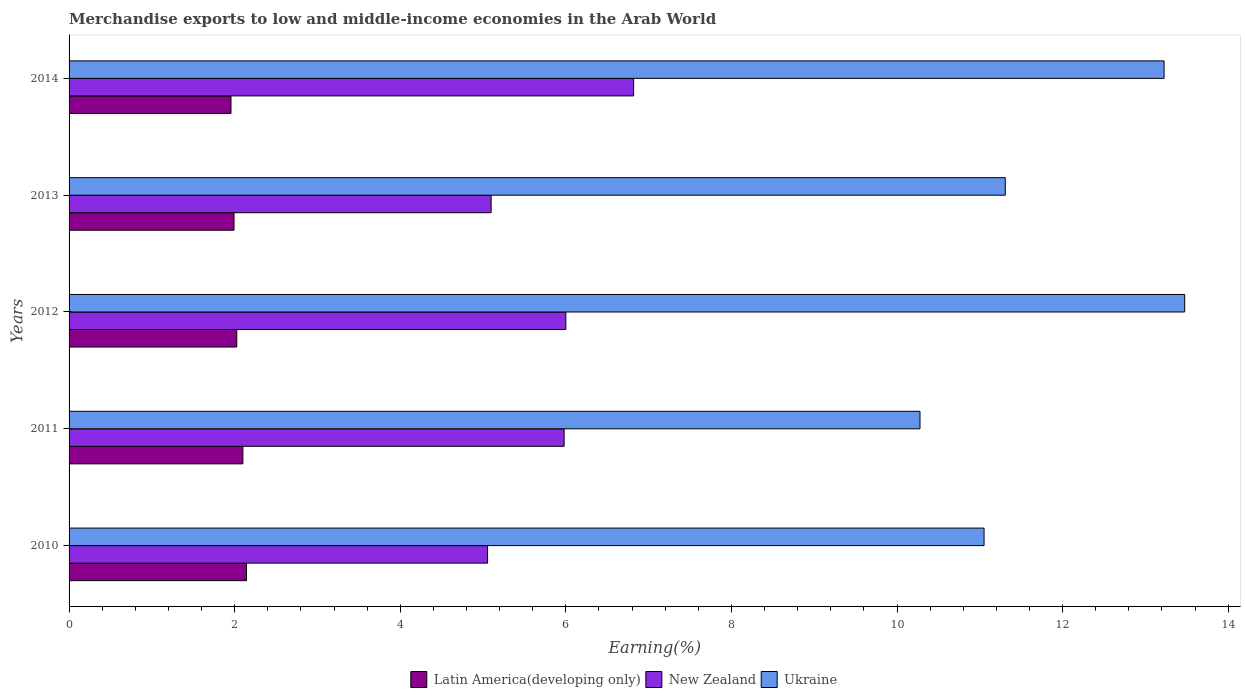How many different coloured bars are there?
Provide a short and direct response. 3. How many groups of bars are there?
Make the answer very short. 5. Are the number of bars on each tick of the Y-axis equal?
Give a very brief answer. Yes. In how many cases, is the number of bars for a given year not equal to the number of legend labels?
Your answer should be very brief. 0. What is the percentage of amount earned from merchandise exports in New Zealand in 2011?
Give a very brief answer. 5.98. Across all years, what is the maximum percentage of amount earned from merchandise exports in Ukraine?
Keep it short and to the point. 13.47. Across all years, what is the minimum percentage of amount earned from merchandise exports in Ukraine?
Your response must be concise. 10.28. In which year was the percentage of amount earned from merchandise exports in New Zealand maximum?
Offer a very short reply. 2014. What is the total percentage of amount earned from merchandise exports in Latin America(developing only) in the graph?
Your response must be concise. 10.22. What is the difference between the percentage of amount earned from merchandise exports in New Zealand in 2011 and that in 2012?
Your response must be concise. -0.02. What is the difference between the percentage of amount earned from merchandise exports in New Zealand in 2011 and the percentage of amount earned from merchandise exports in Latin America(developing only) in 2012?
Offer a very short reply. 3.95. What is the average percentage of amount earned from merchandise exports in Ukraine per year?
Your answer should be compact. 11.87. In the year 2014, what is the difference between the percentage of amount earned from merchandise exports in New Zealand and percentage of amount earned from merchandise exports in Latin America(developing only)?
Give a very brief answer. 4.86. What is the ratio of the percentage of amount earned from merchandise exports in Latin America(developing only) in 2011 to that in 2014?
Give a very brief answer. 1.07. What is the difference between the highest and the second highest percentage of amount earned from merchandise exports in Latin America(developing only)?
Offer a terse response. 0.04. What is the difference between the highest and the lowest percentage of amount earned from merchandise exports in Ukraine?
Provide a short and direct response. 3.2. Is the sum of the percentage of amount earned from merchandise exports in Latin America(developing only) in 2011 and 2014 greater than the maximum percentage of amount earned from merchandise exports in Ukraine across all years?
Ensure brevity in your answer.  No. What does the 1st bar from the top in 2011 represents?
Your response must be concise. Ukraine. What does the 3rd bar from the bottom in 2011 represents?
Ensure brevity in your answer.  Ukraine. What is the difference between two consecutive major ticks on the X-axis?
Ensure brevity in your answer.  2. Are the values on the major ticks of X-axis written in scientific E-notation?
Your answer should be very brief. No. Does the graph contain any zero values?
Make the answer very short. No. How many legend labels are there?
Keep it short and to the point. 3. How are the legend labels stacked?
Your answer should be very brief. Horizontal. What is the title of the graph?
Your answer should be very brief. Merchandise exports to low and middle-income economies in the Arab World. What is the label or title of the X-axis?
Your answer should be very brief. Earning(%). What is the label or title of the Y-axis?
Ensure brevity in your answer.  Years. What is the Earning(%) in Latin America(developing only) in 2010?
Your answer should be compact. 2.14. What is the Earning(%) in New Zealand in 2010?
Offer a very short reply. 5.05. What is the Earning(%) of Ukraine in 2010?
Your answer should be compact. 11.05. What is the Earning(%) in Latin America(developing only) in 2011?
Your response must be concise. 2.1. What is the Earning(%) in New Zealand in 2011?
Keep it short and to the point. 5.98. What is the Earning(%) of Ukraine in 2011?
Offer a very short reply. 10.28. What is the Earning(%) in Latin America(developing only) in 2012?
Keep it short and to the point. 2.03. What is the Earning(%) in New Zealand in 2012?
Your response must be concise. 6. What is the Earning(%) in Ukraine in 2012?
Your answer should be very brief. 13.47. What is the Earning(%) of Latin America(developing only) in 2013?
Give a very brief answer. 1.99. What is the Earning(%) in New Zealand in 2013?
Offer a very short reply. 5.1. What is the Earning(%) of Ukraine in 2013?
Give a very brief answer. 11.31. What is the Earning(%) in Latin America(developing only) in 2014?
Provide a short and direct response. 1.96. What is the Earning(%) of New Zealand in 2014?
Your response must be concise. 6.82. What is the Earning(%) in Ukraine in 2014?
Offer a terse response. 13.23. Across all years, what is the maximum Earning(%) in Latin America(developing only)?
Your answer should be very brief. 2.14. Across all years, what is the maximum Earning(%) in New Zealand?
Give a very brief answer. 6.82. Across all years, what is the maximum Earning(%) of Ukraine?
Make the answer very short. 13.47. Across all years, what is the minimum Earning(%) of Latin America(developing only)?
Offer a very short reply. 1.96. Across all years, what is the minimum Earning(%) in New Zealand?
Ensure brevity in your answer.  5.05. Across all years, what is the minimum Earning(%) of Ukraine?
Make the answer very short. 10.28. What is the total Earning(%) of Latin America(developing only) in the graph?
Provide a short and direct response. 10.22. What is the total Earning(%) of New Zealand in the graph?
Make the answer very short. 28.95. What is the total Earning(%) of Ukraine in the graph?
Your answer should be very brief. 59.34. What is the difference between the Earning(%) in Latin America(developing only) in 2010 and that in 2011?
Make the answer very short. 0.04. What is the difference between the Earning(%) of New Zealand in 2010 and that in 2011?
Your response must be concise. -0.92. What is the difference between the Earning(%) in Ukraine in 2010 and that in 2011?
Keep it short and to the point. 0.77. What is the difference between the Earning(%) of Latin America(developing only) in 2010 and that in 2012?
Give a very brief answer. 0.12. What is the difference between the Earning(%) of New Zealand in 2010 and that in 2012?
Offer a terse response. -0.95. What is the difference between the Earning(%) of Ukraine in 2010 and that in 2012?
Offer a very short reply. -2.42. What is the difference between the Earning(%) in Latin America(developing only) in 2010 and that in 2013?
Provide a succinct answer. 0.15. What is the difference between the Earning(%) of New Zealand in 2010 and that in 2013?
Give a very brief answer. -0.04. What is the difference between the Earning(%) of Ukraine in 2010 and that in 2013?
Keep it short and to the point. -0.26. What is the difference between the Earning(%) of Latin America(developing only) in 2010 and that in 2014?
Give a very brief answer. 0.19. What is the difference between the Earning(%) in New Zealand in 2010 and that in 2014?
Your answer should be compact. -1.76. What is the difference between the Earning(%) of Ukraine in 2010 and that in 2014?
Provide a short and direct response. -2.17. What is the difference between the Earning(%) of Latin America(developing only) in 2011 and that in 2012?
Give a very brief answer. 0.07. What is the difference between the Earning(%) of New Zealand in 2011 and that in 2012?
Your answer should be compact. -0.02. What is the difference between the Earning(%) in Ukraine in 2011 and that in 2012?
Your answer should be very brief. -3.2. What is the difference between the Earning(%) of Latin America(developing only) in 2011 and that in 2013?
Your answer should be compact. 0.11. What is the difference between the Earning(%) of New Zealand in 2011 and that in 2013?
Ensure brevity in your answer.  0.88. What is the difference between the Earning(%) of Ukraine in 2011 and that in 2013?
Ensure brevity in your answer.  -1.03. What is the difference between the Earning(%) of Latin America(developing only) in 2011 and that in 2014?
Provide a short and direct response. 0.14. What is the difference between the Earning(%) in New Zealand in 2011 and that in 2014?
Offer a very short reply. -0.84. What is the difference between the Earning(%) of Ukraine in 2011 and that in 2014?
Ensure brevity in your answer.  -2.95. What is the difference between the Earning(%) in Latin America(developing only) in 2012 and that in 2013?
Your response must be concise. 0.03. What is the difference between the Earning(%) in New Zealand in 2012 and that in 2013?
Ensure brevity in your answer.  0.9. What is the difference between the Earning(%) in Ukraine in 2012 and that in 2013?
Offer a terse response. 2.17. What is the difference between the Earning(%) of Latin America(developing only) in 2012 and that in 2014?
Provide a succinct answer. 0.07. What is the difference between the Earning(%) in New Zealand in 2012 and that in 2014?
Provide a succinct answer. -0.82. What is the difference between the Earning(%) of Ukraine in 2012 and that in 2014?
Make the answer very short. 0.25. What is the difference between the Earning(%) of Latin America(developing only) in 2013 and that in 2014?
Give a very brief answer. 0.04. What is the difference between the Earning(%) of New Zealand in 2013 and that in 2014?
Offer a terse response. -1.72. What is the difference between the Earning(%) of Ukraine in 2013 and that in 2014?
Keep it short and to the point. -1.92. What is the difference between the Earning(%) of Latin America(developing only) in 2010 and the Earning(%) of New Zealand in 2011?
Ensure brevity in your answer.  -3.84. What is the difference between the Earning(%) of Latin America(developing only) in 2010 and the Earning(%) of Ukraine in 2011?
Offer a very short reply. -8.13. What is the difference between the Earning(%) of New Zealand in 2010 and the Earning(%) of Ukraine in 2011?
Your answer should be compact. -5.22. What is the difference between the Earning(%) of Latin America(developing only) in 2010 and the Earning(%) of New Zealand in 2012?
Provide a short and direct response. -3.86. What is the difference between the Earning(%) of Latin America(developing only) in 2010 and the Earning(%) of Ukraine in 2012?
Ensure brevity in your answer.  -11.33. What is the difference between the Earning(%) of New Zealand in 2010 and the Earning(%) of Ukraine in 2012?
Provide a succinct answer. -8.42. What is the difference between the Earning(%) in Latin America(developing only) in 2010 and the Earning(%) in New Zealand in 2013?
Keep it short and to the point. -2.95. What is the difference between the Earning(%) of Latin America(developing only) in 2010 and the Earning(%) of Ukraine in 2013?
Your answer should be very brief. -9.17. What is the difference between the Earning(%) in New Zealand in 2010 and the Earning(%) in Ukraine in 2013?
Provide a short and direct response. -6.25. What is the difference between the Earning(%) of Latin America(developing only) in 2010 and the Earning(%) of New Zealand in 2014?
Keep it short and to the point. -4.68. What is the difference between the Earning(%) in Latin America(developing only) in 2010 and the Earning(%) in Ukraine in 2014?
Offer a terse response. -11.08. What is the difference between the Earning(%) in New Zealand in 2010 and the Earning(%) in Ukraine in 2014?
Your answer should be very brief. -8.17. What is the difference between the Earning(%) of Latin America(developing only) in 2011 and the Earning(%) of New Zealand in 2012?
Your answer should be very brief. -3.9. What is the difference between the Earning(%) of Latin America(developing only) in 2011 and the Earning(%) of Ukraine in 2012?
Give a very brief answer. -11.38. What is the difference between the Earning(%) of New Zealand in 2011 and the Earning(%) of Ukraine in 2012?
Your answer should be compact. -7.5. What is the difference between the Earning(%) of Latin America(developing only) in 2011 and the Earning(%) of New Zealand in 2013?
Provide a short and direct response. -3. What is the difference between the Earning(%) of Latin America(developing only) in 2011 and the Earning(%) of Ukraine in 2013?
Provide a succinct answer. -9.21. What is the difference between the Earning(%) in New Zealand in 2011 and the Earning(%) in Ukraine in 2013?
Provide a succinct answer. -5.33. What is the difference between the Earning(%) of Latin America(developing only) in 2011 and the Earning(%) of New Zealand in 2014?
Make the answer very short. -4.72. What is the difference between the Earning(%) of Latin America(developing only) in 2011 and the Earning(%) of Ukraine in 2014?
Keep it short and to the point. -11.13. What is the difference between the Earning(%) in New Zealand in 2011 and the Earning(%) in Ukraine in 2014?
Give a very brief answer. -7.25. What is the difference between the Earning(%) of Latin America(developing only) in 2012 and the Earning(%) of New Zealand in 2013?
Keep it short and to the point. -3.07. What is the difference between the Earning(%) of Latin America(developing only) in 2012 and the Earning(%) of Ukraine in 2013?
Keep it short and to the point. -9.28. What is the difference between the Earning(%) of New Zealand in 2012 and the Earning(%) of Ukraine in 2013?
Your answer should be compact. -5.31. What is the difference between the Earning(%) of Latin America(developing only) in 2012 and the Earning(%) of New Zealand in 2014?
Ensure brevity in your answer.  -4.79. What is the difference between the Earning(%) of Latin America(developing only) in 2012 and the Earning(%) of Ukraine in 2014?
Keep it short and to the point. -11.2. What is the difference between the Earning(%) in New Zealand in 2012 and the Earning(%) in Ukraine in 2014?
Ensure brevity in your answer.  -7.23. What is the difference between the Earning(%) in Latin America(developing only) in 2013 and the Earning(%) in New Zealand in 2014?
Ensure brevity in your answer.  -4.83. What is the difference between the Earning(%) of Latin America(developing only) in 2013 and the Earning(%) of Ukraine in 2014?
Make the answer very short. -11.23. What is the difference between the Earning(%) in New Zealand in 2013 and the Earning(%) in Ukraine in 2014?
Your answer should be compact. -8.13. What is the average Earning(%) in Latin America(developing only) per year?
Your answer should be compact. 2.04. What is the average Earning(%) of New Zealand per year?
Provide a succinct answer. 5.79. What is the average Earning(%) of Ukraine per year?
Offer a terse response. 11.87. In the year 2010, what is the difference between the Earning(%) of Latin America(developing only) and Earning(%) of New Zealand?
Offer a terse response. -2.91. In the year 2010, what is the difference between the Earning(%) in Latin America(developing only) and Earning(%) in Ukraine?
Your answer should be very brief. -8.91. In the year 2010, what is the difference between the Earning(%) of New Zealand and Earning(%) of Ukraine?
Your answer should be compact. -6. In the year 2011, what is the difference between the Earning(%) in Latin America(developing only) and Earning(%) in New Zealand?
Make the answer very short. -3.88. In the year 2011, what is the difference between the Earning(%) in Latin America(developing only) and Earning(%) in Ukraine?
Your response must be concise. -8.18. In the year 2011, what is the difference between the Earning(%) in New Zealand and Earning(%) in Ukraine?
Offer a terse response. -4.3. In the year 2012, what is the difference between the Earning(%) in Latin America(developing only) and Earning(%) in New Zealand?
Offer a very short reply. -3.97. In the year 2012, what is the difference between the Earning(%) in Latin America(developing only) and Earning(%) in Ukraine?
Ensure brevity in your answer.  -11.45. In the year 2012, what is the difference between the Earning(%) in New Zealand and Earning(%) in Ukraine?
Your response must be concise. -7.47. In the year 2013, what is the difference between the Earning(%) of Latin America(developing only) and Earning(%) of New Zealand?
Ensure brevity in your answer.  -3.11. In the year 2013, what is the difference between the Earning(%) of Latin America(developing only) and Earning(%) of Ukraine?
Your answer should be compact. -9.32. In the year 2013, what is the difference between the Earning(%) in New Zealand and Earning(%) in Ukraine?
Keep it short and to the point. -6.21. In the year 2014, what is the difference between the Earning(%) of Latin America(developing only) and Earning(%) of New Zealand?
Give a very brief answer. -4.86. In the year 2014, what is the difference between the Earning(%) of Latin America(developing only) and Earning(%) of Ukraine?
Make the answer very short. -11.27. In the year 2014, what is the difference between the Earning(%) of New Zealand and Earning(%) of Ukraine?
Give a very brief answer. -6.41. What is the ratio of the Earning(%) in Latin America(developing only) in 2010 to that in 2011?
Your response must be concise. 1.02. What is the ratio of the Earning(%) of New Zealand in 2010 to that in 2011?
Give a very brief answer. 0.85. What is the ratio of the Earning(%) in Ukraine in 2010 to that in 2011?
Provide a short and direct response. 1.08. What is the ratio of the Earning(%) of Latin America(developing only) in 2010 to that in 2012?
Keep it short and to the point. 1.06. What is the ratio of the Earning(%) of New Zealand in 2010 to that in 2012?
Provide a short and direct response. 0.84. What is the ratio of the Earning(%) in Ukraine in 2010 to that in 2012?
Offer a terse response. 0.82. What is the ratio of the Earning(%) of Latin America(developing only) in 2010 to that in 2013?
Your response must be concise. 1.08. What is the ratio of the Earning(%) of Ukraine in 2010 to that in 2013?
Your answer should be very brief. 0.98. What is the ratio of the Earning(%) of Latin America(developing only) in 2010 to that in 2014?
Your answer should be very brief. 1.1. What is the ratio of the Earning(%) of New Zealand in 2010 to that in 2014?
Your response must be concise. 0.74. What is the ratio of the Earning(%) in Ukraine in 2010 to that in 2014?
Keep it short and to the point. 0.84. What is the ratio of the Earning(%) of Latin America(developing only) in 2011 to that in 2012?
Your answer should be compact. 1.04. What is the ratio of the Earning(%) in New Zealand in 2011 to that in 2012?
Your response must be concise. 1. What is the ratio of the Earning(%) in Ukraine in 2011 to that in 2012?
Your response must be concise. 0.76. What is the ratio of the Earning(%) in Latin America(developing only) in 2011 to that in 2013?
Keep it short and to the point. 1.05. What is the ratio of the Earning(%) of New Zealand in 2011 to that in 2013?
Ensure brevity in your answer.  1.17. What is the ratio of the Earning(%) of Ukraine in 2011 to that in 2013?
Your answer should be compact. 0.91. What is the ratio of the Earning(%) of Latin America(developing only) in 2011 to that in 2014?
Give a very brief answer. 1.07. What is the ratio of the Earning(%) in New Zealand in 2011 to that in 2014?
Offer a terse response. 0.88. What is the ratio of the Earning(%) in Ukraine in 2011 to that in 2014?
Provide a succinct answer. 0.78. What is the ratio of the Earning(%) in Latin America(developing only) in 2012 to that in 2013?
Ensure brevity in your answer.  1.02. What is the ratio of the Earning(%) in New Zealand in 2012 to that in 2013?
Make the answer very short. 1.18. What is the ratio of the Earning(%) of Ukraine in 2012 to that in 2013?
Your answer should be compact. 1.19. What is the ratio of the Earning(%) of Latin America(developing only) in 2012 to that in 2014?
Give a very brief answer. 1.04. What is the ratio of the Earning(%) of New Zealand in 2012 to that in 2014?
Your answer should be very brief. 0.88. What is the ratio of the Earning(%) of Ukraine in 2012 to that in 2014?
Provide a short and direct response. 1.02. What is the ratio of the Earning(%) of Latin America(developing only) in 2013 to that in 2014?
Provide a succinct answer. 1.02. What is the ratio of the Earning(%) of New Zealand in 2013 to that in 2014?
Your answer should be very brief. 0.75. What is the ratio of the Earning(%) in Ukraine in 2013 to that in 2014?
Your answer should be compact. 0.85. What is the difference between the highest and the second highest Earning(%) in Latin America(developing only)?
Your response must be concise. 0.04. What is the difference between the highest and the second highest Earning(%) in New Zealand?
Offer a very short reply. 0.82. What is the difference between the highest and the second highest Earning(%) of Ukraine?
Provide a succinct answer. 0.25. What is the difference between the highest and the lowest Earning(%) in Latin America(developing only)?
Your answer should be compact. 0.19. What is the difference between the highest and the lowest Earning(%) of New Zealand?
Your answer should be very brief. 1.76. What is the difference between the highest and the lowest Earning(%) of Ukraine?
Ensure brevity in your answer.  3.2. 